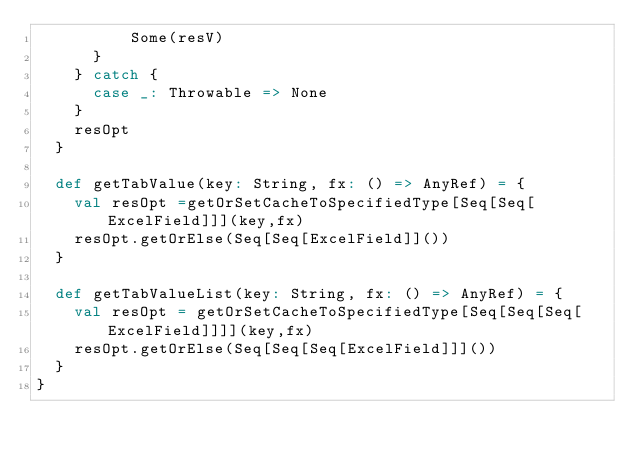<code> <loc_0><loc_0><loc_500><loc_500><_Scala_>          Some(resV)
      }
    } catch {
      case _: Throwable => None
    }
    resOpt
  }

  def getTabValue(key: String, fx: () => AnyRef) = {
    val resOpt =getOrSetCacheToSpecifiedType[Seq[Seq[ExcelField]]](key,fx)
    resOpt.getOrElse(Seq[Seq[ExcelField]]())
  }

  def getTabValueList(key: String, fx: () => AnyRef) = {
    val resOpt = getOrSetCacheToSpecifiedType[Seq[Seq[Seq[ExcelField]]]](key,fx)
    resOpt.getOrElse(Seq[Seq[Seq[ExcelField]]]())
  }
}</code> 